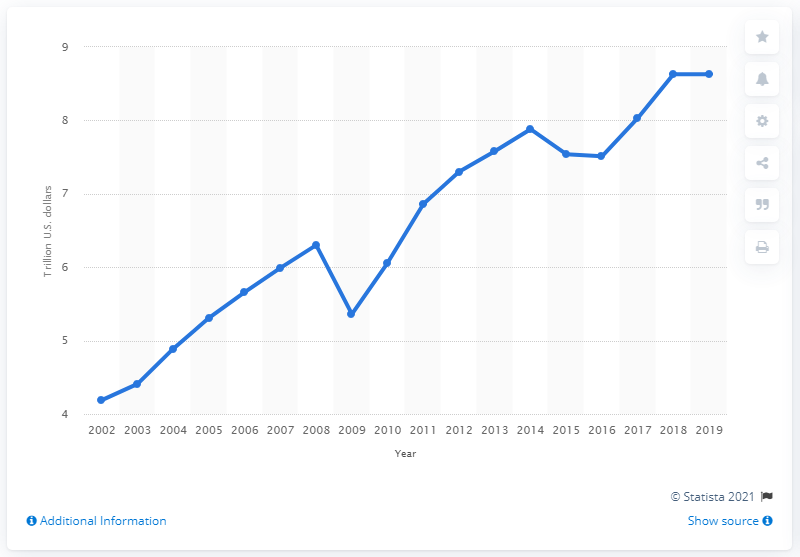Indicate a few pertinent items in this graphic. In 2019, the total goods sales of U.S. merchant wholesalers amounted to 8.63 billion U.S. dollars. 